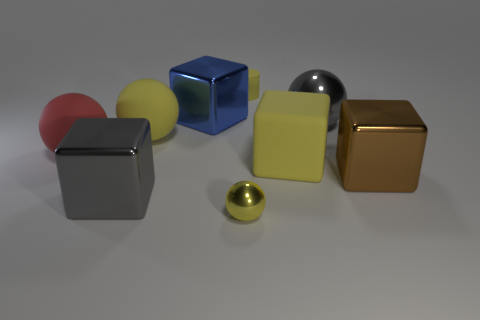Which objects in the image have reflective surfaces? The blue cube, the golden cube, and the two spheres have reflective surfaces, indicating a certain sheen that catches the light and mirrors the surroundings. 